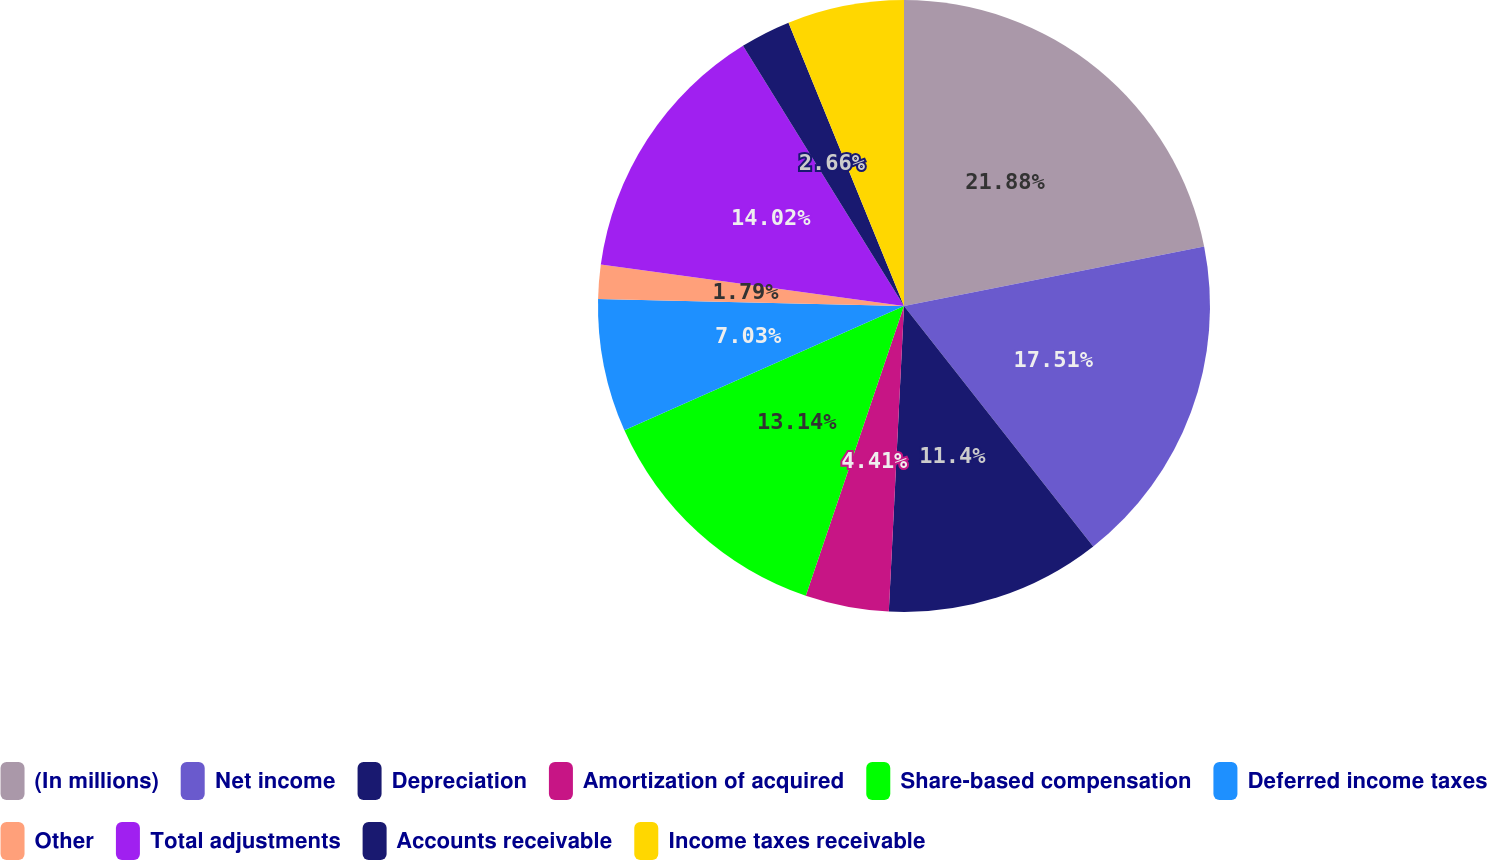Convert chart. <chart><loc_0><loc_0><loc_500><loc_500><pie_chart><fcel>(In millions)<fcel>Net income<fcel>Depreciation<fcel>Amortization of acquired<fcel>Share-based compensation<fcel>Deferred income taxes<fcel>Other<fcel>Total adjustments<fcel>Accounts receivable<fcel>Income taxes receivable<nl><fcel>21.88%<fcel>17.51%<fcel>11.4%<fcel>4.41%<fcel>13.14%<fcel>7.03%<fcel>1.79%<fcel>14.02%<fcel>2.66%<fcel>6.16%<nl></chart> 